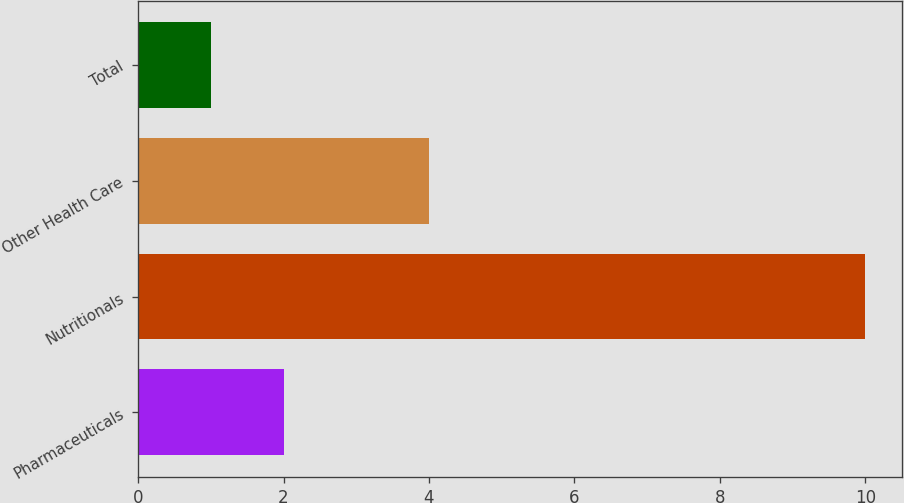Convert chart to OTSL. <chart><loc_0><loc_0><loc_500><loc_500><bar_chart><fcel>Pharmaceuticals<fcel>Nutritionals<fcel>Other Health Care<fcel>Total<nl><fcel>2<fcel>10<fcel>4<fcel>1<nl></chart> 